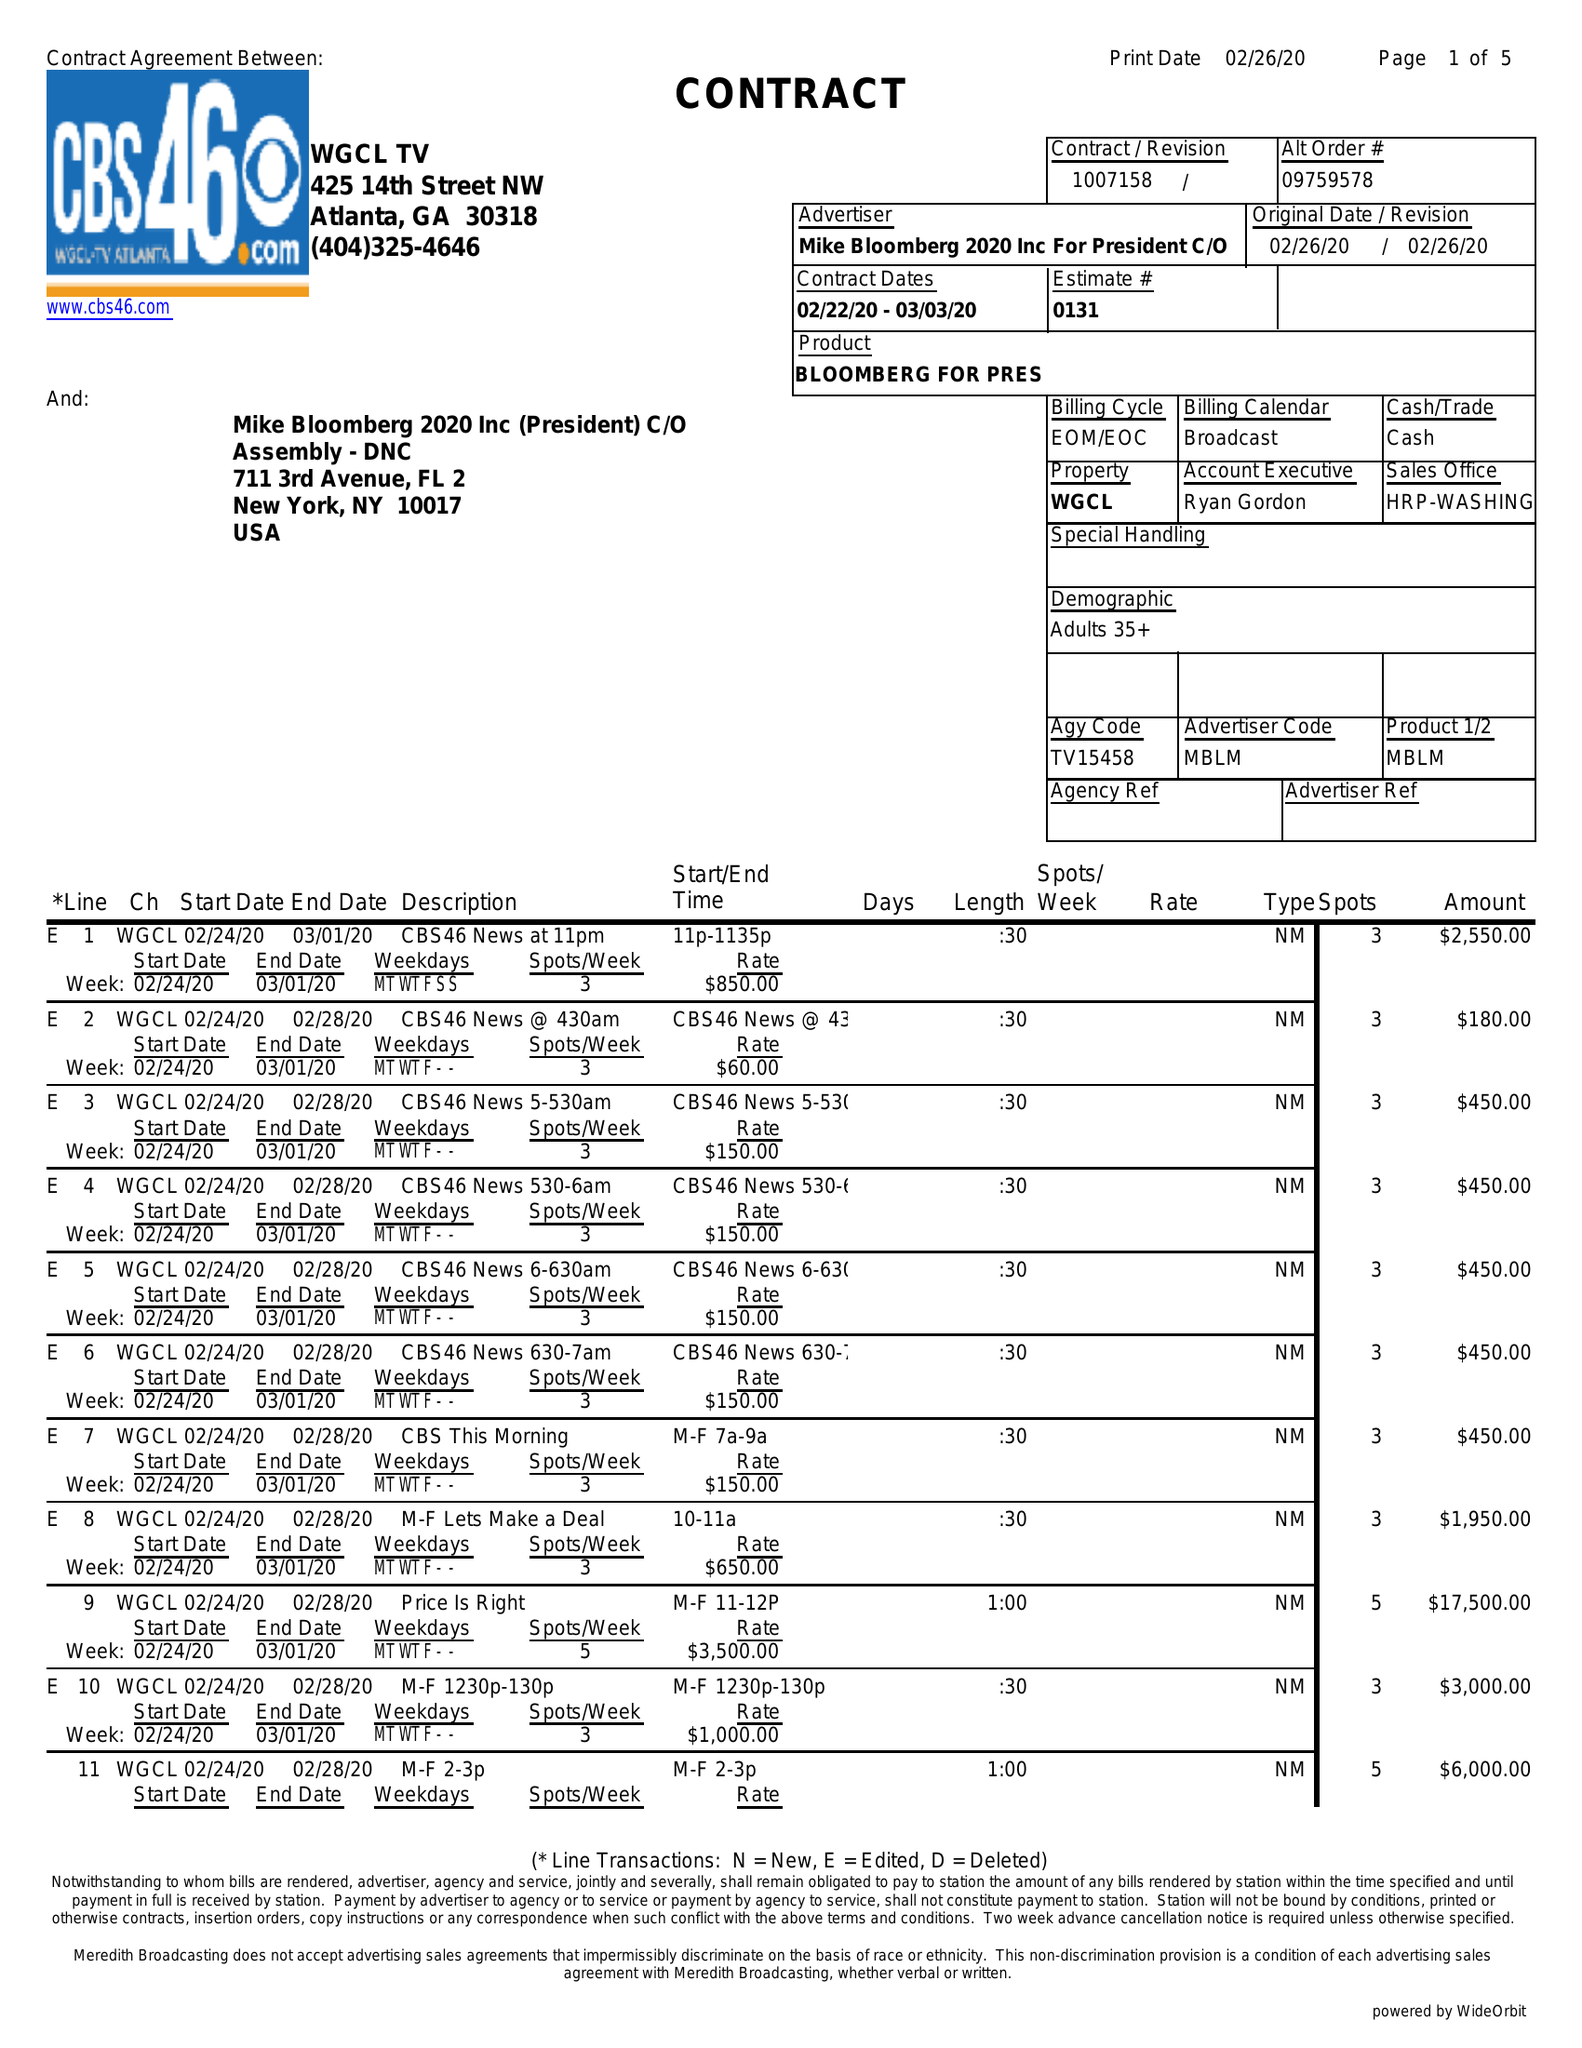What is the value for the contract_num?
Answer the question using a single word or phrase. 1007158 